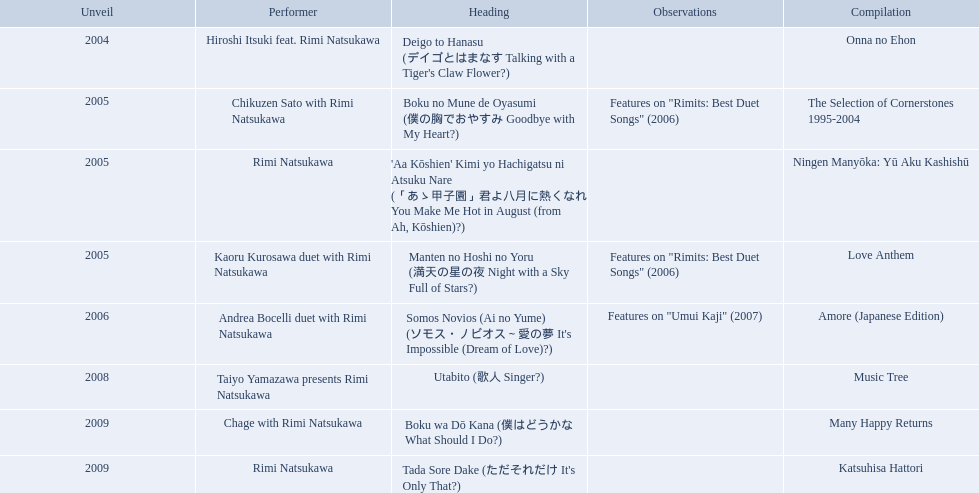When was onna no ehon released? 2004. When was the selection of cornerstones 1995-2004 released? 2005. What was released in 2008? Music Tree. 